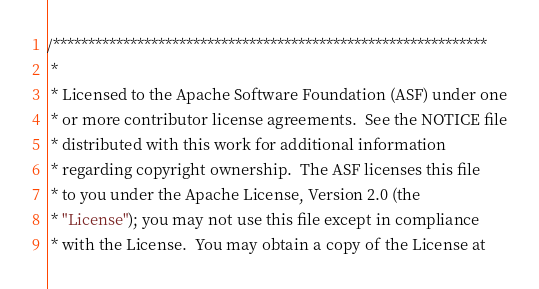<code> <loc_0><loc_0><loc_500><loc_500><_CSS_>/**************************************************************
 * 
 * Licensed to the Apache Software Foundation (ASF) under one
 * or more contributor license agreements.  See the NOTICE file
 * distributed with this work for additional information
 * regarding copyright ownership.  The ASF licenses this file
 * to you under the Apache License, Version 2.0 (the
 * "License"); you may not use this file except in compliance
 * with the License.  You may obtain a copy of the License at</code> 